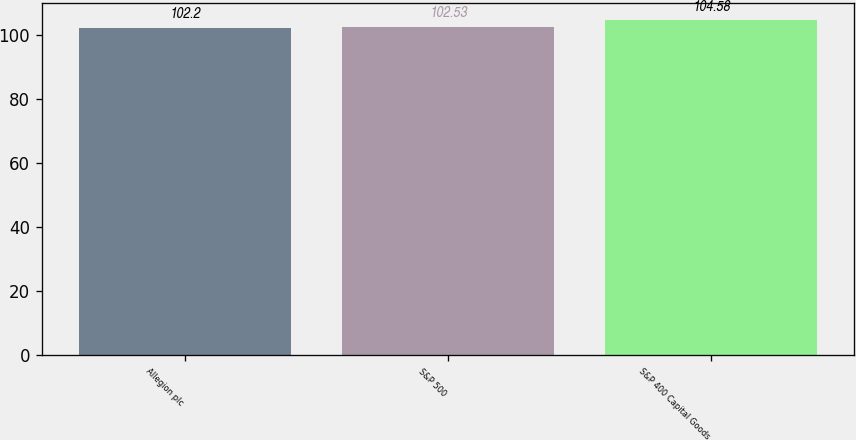<chart> <loc_0><loc_0><loc_500><loc_500><bar_chart><fcel>Allegion plc<fcel>S&P 500<fcel>S&P 400 Capital Goods<nl><fcel>102.2<fcel>102.53<fcel>104.58<nl></chart> 